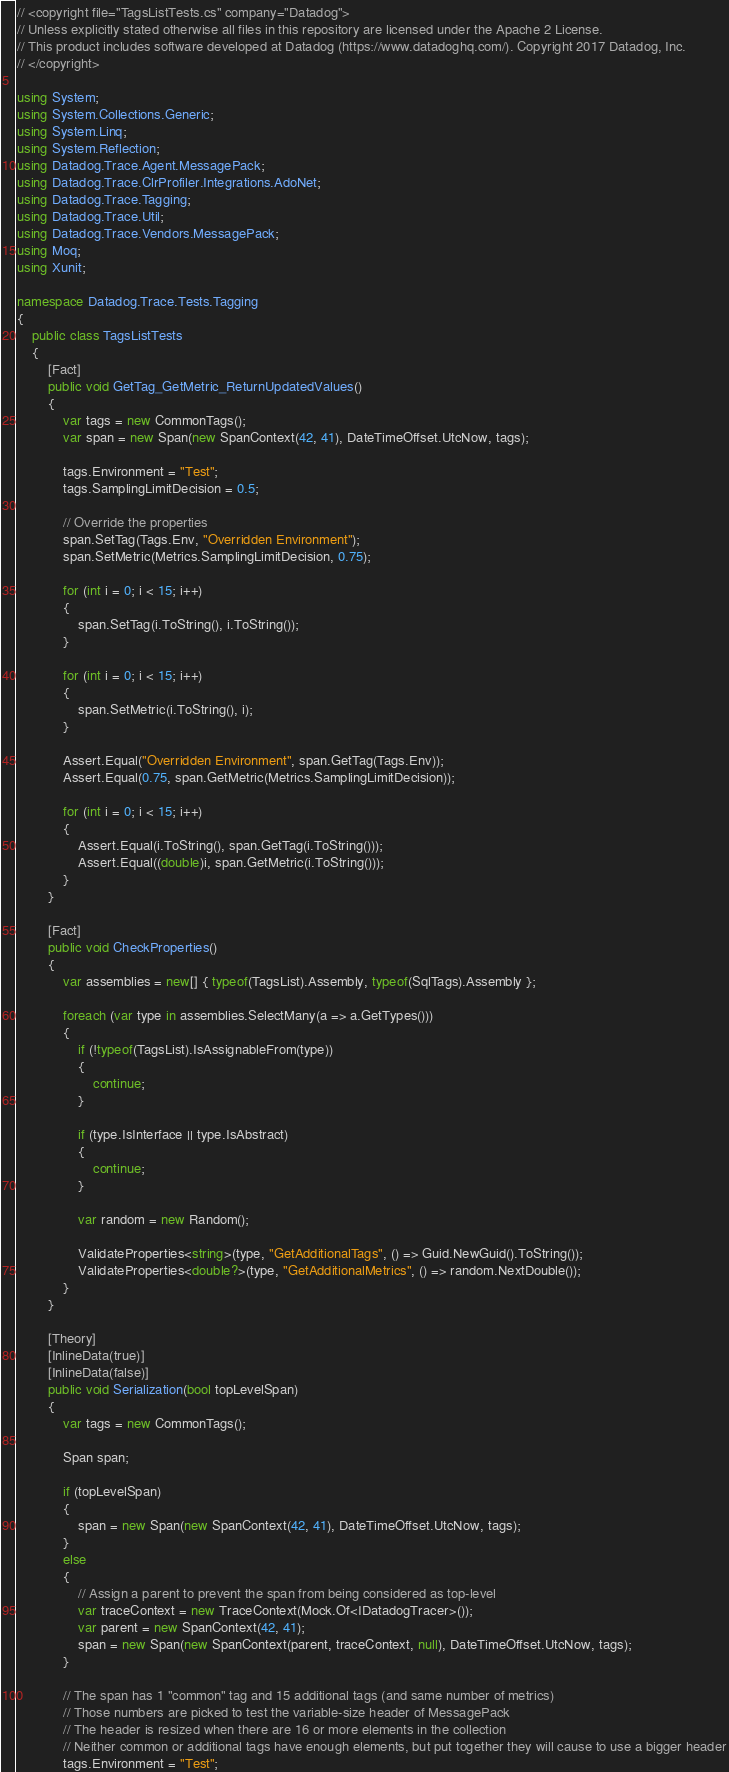<code> <loc_0><loc_0><loc_500><loc_500><_C#_>// <copyright file="TagsListTests.cs" company="Datadog">
// Unless explicitly stated otherwise all files in this repository are licensed under the Apache 2 License.
// This product includes software developed at Datadog (https://www.datadoghq.com/). Copyright 2017 Datadog, Inc.
// </copyright>

using System;
using System.Collections.Generic;
using System.Linq;
using System.Reflection;
using Datadog.Trace.Agent.MessagePack;
using Datadog.Trace.ClrProfiler.Integrations.AdoNet;
using Datadog.Trace.Tagging;
using Datadog.Trace.Util;
using Datadog.Trace.Vendors.MessagePack;
using Moq;
using Xunit;

namespace Datadog.Trace.Tests.Tagging
{
    public class TagsListTests
    {
        [Fact]
        public void GetTag_GetMetric_ReturnUpdatedValues()
        {
            var tags = new CommonTags();
            var span = new Span(new SpanContext(42, 41), DateTimeOffset.UtcNow, tags);

            tags.Environment = "Test";
            tags.SamplingLimitDecision = 0.5;

            // Override the properties
            span.SetTag(Tags.Env, "Overridden Environment");
            span.SetMetric(Metrics.SamplingLimitDecision, 0.75);

            for (int i = 0; i < 15; i++)
            {
                span.SetTag(i.ToString(), i.ToString());
            }

            for (int i = 0; i < 15; i++)
            {
                span.SetMetric(i.ToString(), i);
            }

            Assert.Equal("Overridden Environment", span.GetTag(Tags.Env));
            Assert.Equal(0.75, span.GetMetric(Metrics.SamplingLimitDecision));

            for (int i = 0; i < 15; i++)
            {
                Assert.Equal(i.ToString(), span.GetTag(i.ToString()));
                Assert.Equal((double)i, span.GetMetric(i.ToString()));
            }
        }

        [Fact]
        public void CheckProperties()
        {
            var assemblies = new[] { typeof(TagsList).Assembly, typeof(SqlTags).Assembly };

            foreach (var type in assemblies.SelectMany(a => a.GetTypes()))
            {
                if (!typeof(TagsList).IsAssignableFrom(type))
                {
                    continue;
                }

                if (type.IsInterface || type.IsAbstract)
                {
                    continue;
                }

                var random = new Random();

                ValidateProperties<string>(type, "GetAdditionalTags", () => Guid.NewGuid().ToString());
                ValidateProperties<double?>(type, "GetAdditionalMetrics", () => random.NextDouble());
            }
        }

        [Theory]
        [InlineData(true)]
        [InlineData(false)]
        public void Serialization(bool topLevelSpan)
        {
            var tags = new CommonTags();

            Span span;

            if (topLevelSpan)
            {
                span = new Span(new SpanContext(42, 41), DateTimeOffset.UtcNow, tags);
            }
            else
            {
                // Assign a parent to prevent the span from being considered as top-level
                var traceContext = new TraceContext(Mock.Of<IDatadogTracer>());
                var parent = new SpanContext(42, 41);
                span = new Span(new SpanContext(parent, traceContext, null), DateTimeOffset.UtcNow, tags);
            }

            // The span has 1 "common" tag and 15 additional tags (and same number of metrics)
            // Those numbers are picked to test the variable-size header of MessagePack
            // The header is resized when there are 16 or more elements in the collection
            // Neither common or additional tags have enough elements, but put together they will cause to use a bigger header
            tags.Environment = "Test";</code> 